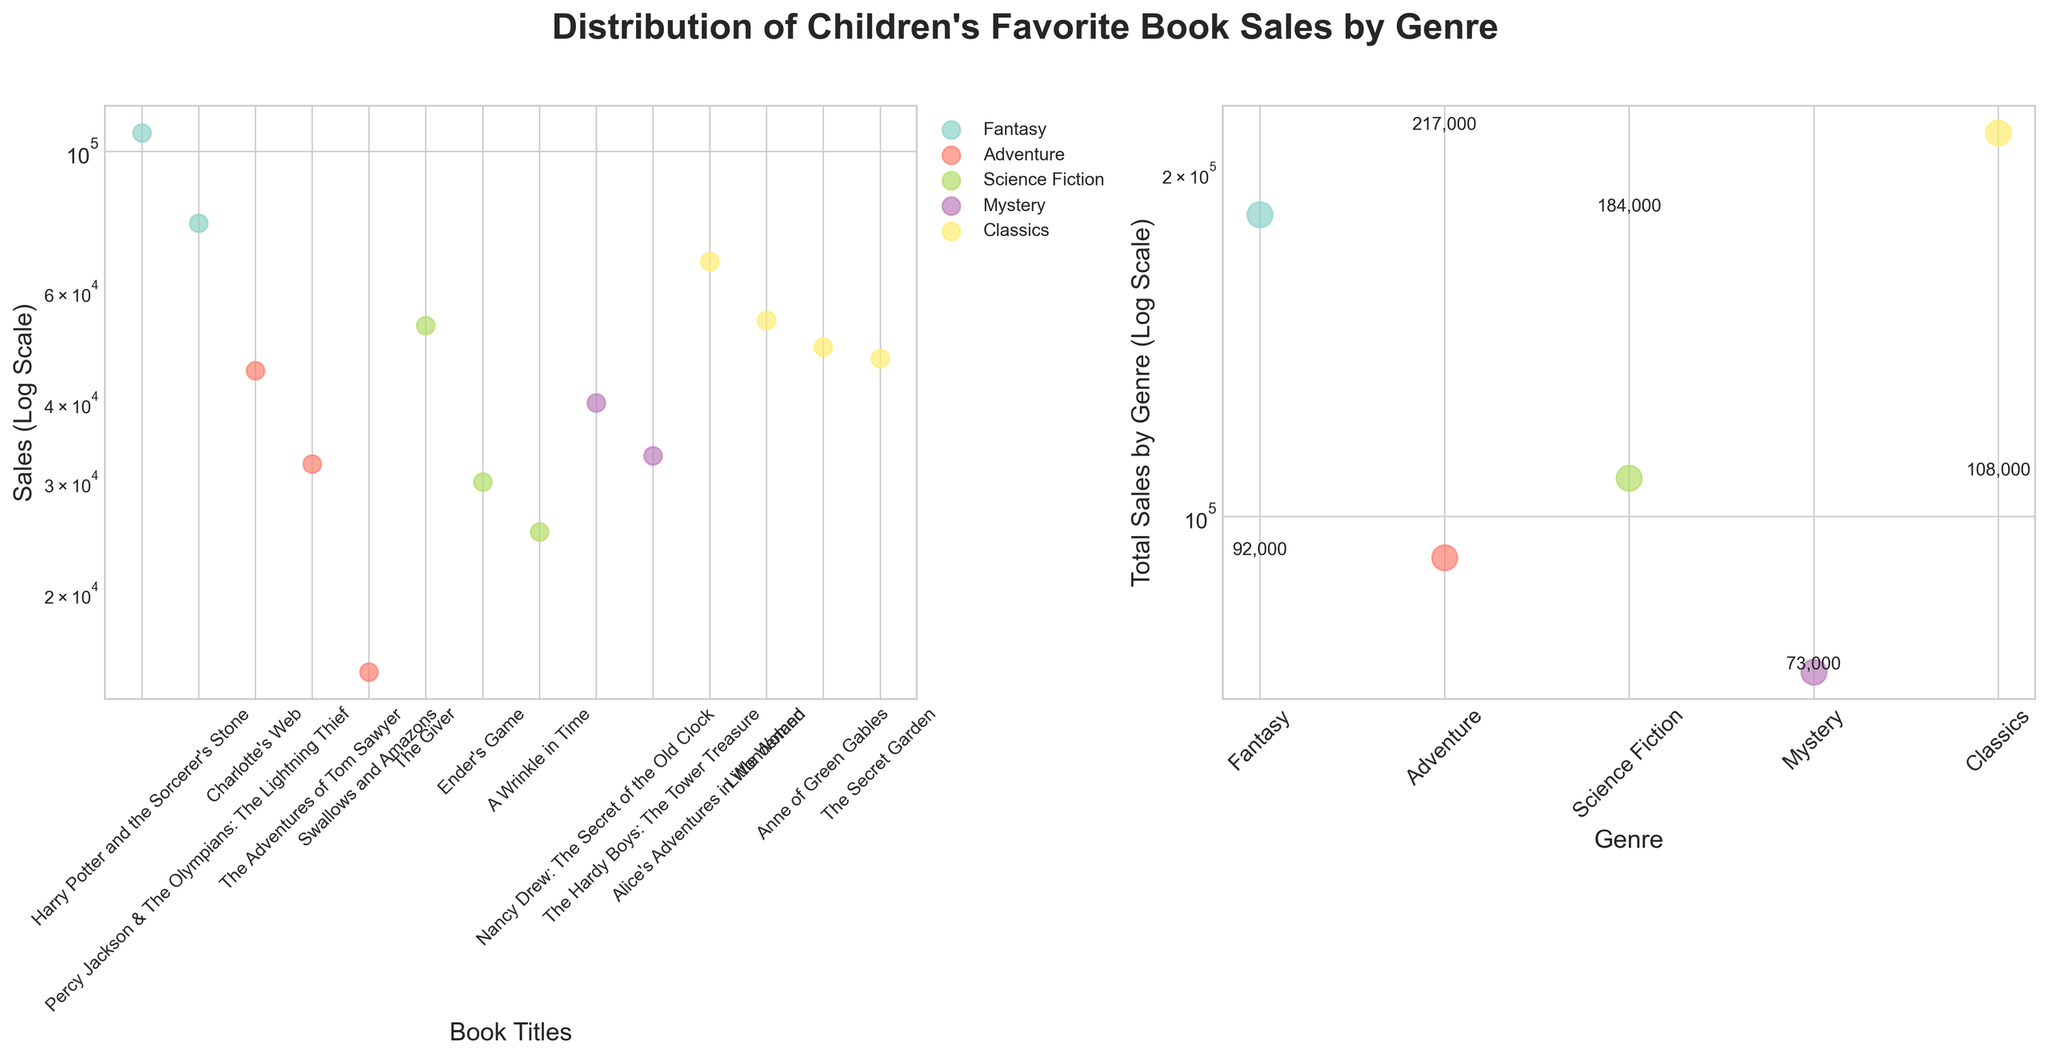What is the title of the figure? The title is written above the two subplots.
Answer: Distribution of Children's Favorite Book Sales by Genre Which axis in the scatter plot shows the book titles? The x-axis in the left subplot shows the book titles.
Answer: x-axis What is the unit of the y-axis in both subplots? The y-axis in both subplots is labeled with a log scale unit for sales.
Answer: Sales (Log Scale) How many genres are represented in the figure? By counting the distinct colors and referencing the legend, you can see there are five genres.
Answer: Five Which book has the highest sales? By looking at the book with the highest y-value in the left subplot, "Harry Potter and the Sorcerer's Stone" has the highest sales.
Answer: Harry Potter and the Sorcerer's Stone Which genre has the lowest total sales? By comparing the total sales values indicated in the right subplot, "Adventure" has the lowest total sales.
Answer: Adventure What is the total sales value of the Fantasy genre? The total sales value can be seen as the y-value for the Fantasy marker in the right subplot, which is labeled at approximately 184,000.
Answer: 184,000 Which genres have their sales data points displayed the furthest apart in the figure? By comparing the spread of data points in the left subplot, it is clear that the Fantasy genre's data points are the furthest apart due to the highest and the second highest individual book sales.
Answer: Fantasy Compare the sales of "Nancy Drew: The Secret of the Old Clock" to "The Hardy Boys: The Tower Treasure." Which one has more sales? By comparing their positions along the y-axis in the left subplot, "Nancy Drew: The Secret of the Old Clock" is higher and thus has more sales.
Answer: Nancy Drew: The Secret of the Old Clock What is the primary difference between the y-axes of the two subplots? The left subplot shows individual book sales, while the right subplot shows total sales by genre.
Answer: One shows individual book sales, the other shows total sales by genre 